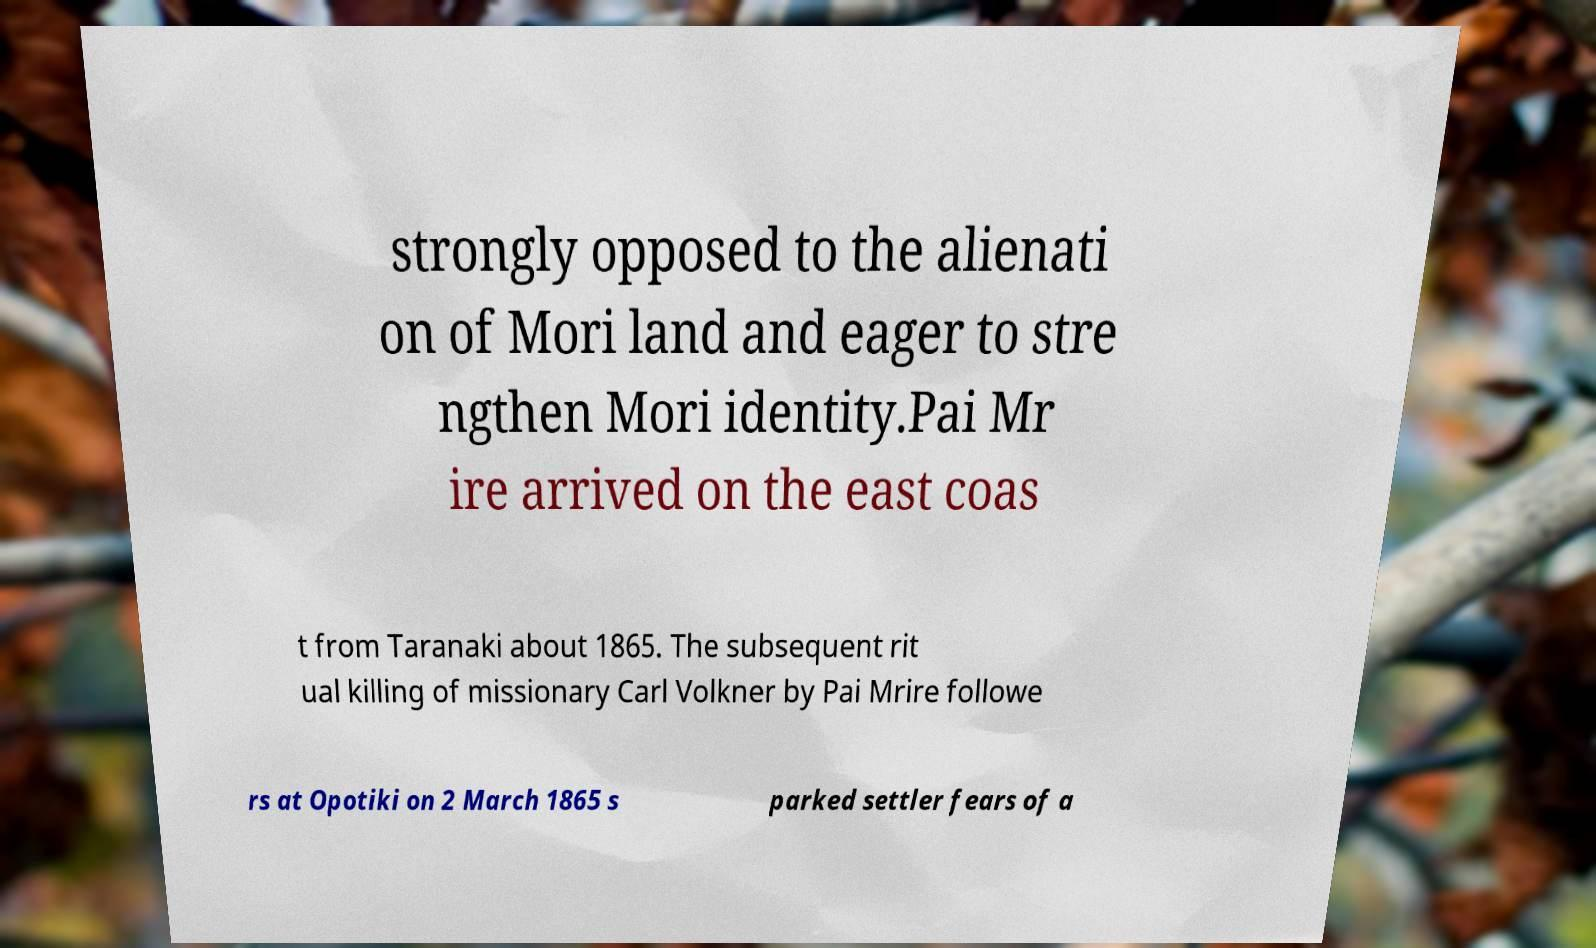For documentation purposes, I need the text within this image transcribed. Could you provide that? strongly opposed to the alienati on of Mori land and eager to stre ngthen Mori identity.Pai Mr ire arrived on the east coas t from Taranaki about 1865. The subsequent rit ual killing of missionary Carl Volkner by Pai Mrire followe rs at Opotiki on 2 March 1865 s parked settler fears of a 